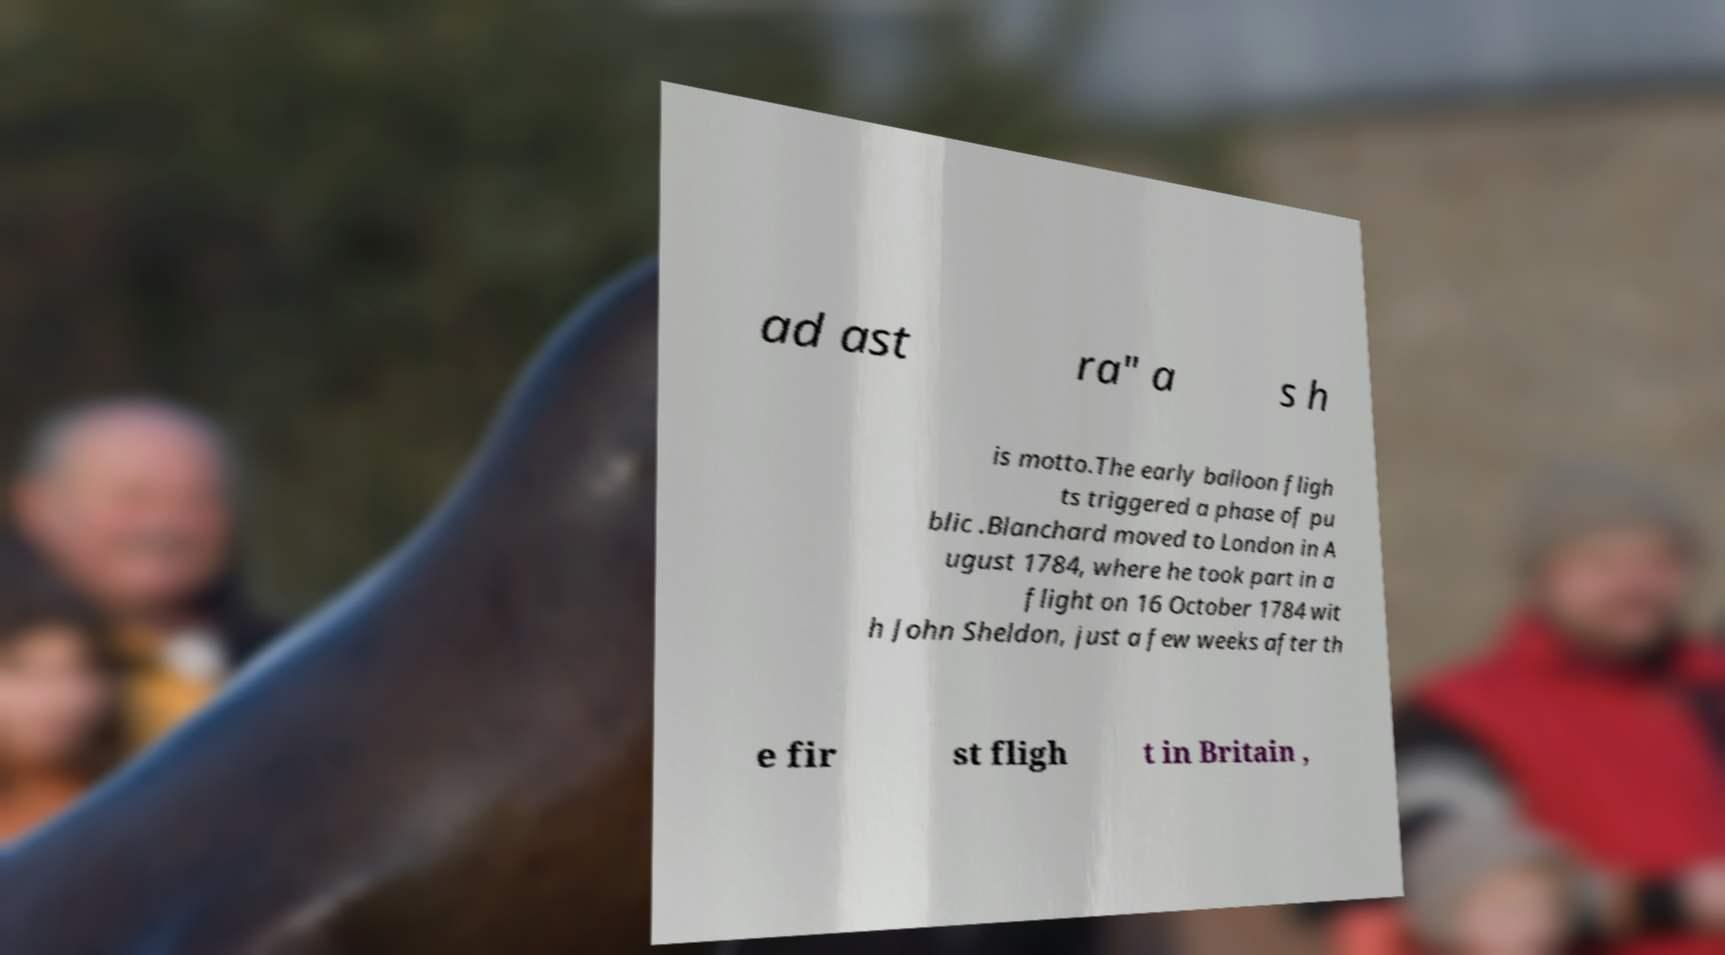Could you extract and type out the text from this image? ad ast ra" a s h is motto.The early balloon fligh ts triggered a phase of pu blic .Blanchard moved to London in A ugust 1784, where he took part in a flight on 16 October 1784 wit h John Sheldon, just a few weeks after th e fir st fligh t in Britain , 